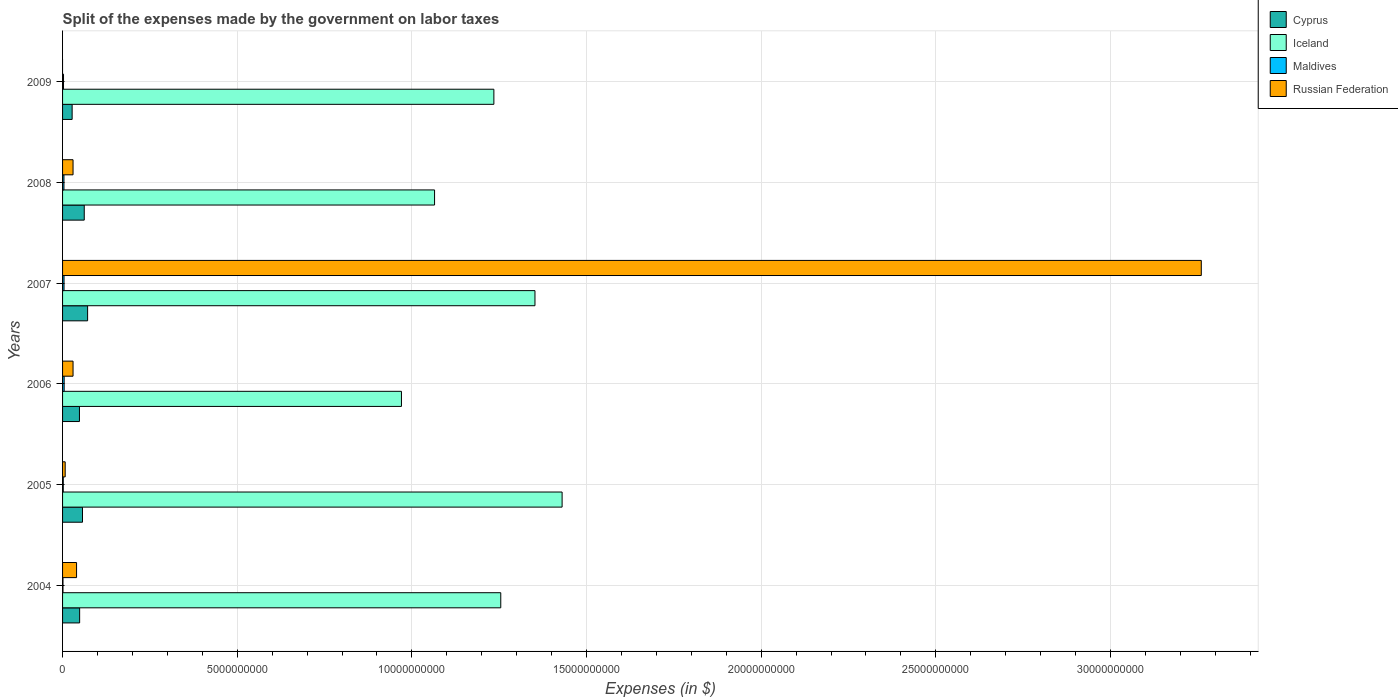How many groups of bars are there?
Make the answer very short. 6. Are the number of bars per tick equal to the number of legend labels?
Your answer should be compact. No. In how many cases, is the number of bars for a given year not equal to the number of legend labels?
Ensure brevity in your answer.  1. What is the expenses made by the government on labor taxes in Maldives in 2005?
Your answer should be very brief. 2.02e+07. Across all years, what is the maximum expenses made by the government on labor taxes in Iceland?
Provide a short and direct response. 1.43e+1. In which year was the expenses made by the government on labor taxes in Cyprus maximum?
Offer a terse response. 2007. What is the total expenses made by the government on labor taxes in Iceland in the graph?
Ensure brevity in your answer.  7.31e+1. What is the difference between the expenses made by the government on labor taxes in Maldives in 2005 and that in 2007?
Make the answer very short. -2.16e+07. What is the difference between the expenses made by the government on labor taxes in Cyprus in 2004 and the expenses made by the government on labor taxes in Russian Federation in 2009?
Provide a succinct answer. 4.89e+08. What is the average expenses made by the government on labor taxes in Cyprus per year?
Your answer should be compact. 5.26e+08. In the year 2007, what is the difference between the expenses made by the government on labor taxes in Maldives and expenses made by the government on labor taxes in Iceland?
Your answer should be very brief. -1.35e+1. In how many years, is the expenses made by the government on labor taxes in Maldives greater than 3000000000 $?
Offer a terse response. 0. What is the ratio of the expenses made by the government on labor taxes in Cyprus in 2006 to that in 2007?
Ensure brevity in your answer.  0.67. Is the expenses made by the government on labor taxes in Iceland in 2005 less than that in 2007?
Your answer should be very brief. No. What is the difference between the highest and the second highest expenses made by the government on labor taxes in Iceland?
Provide a short and direct response. 7.77e+08. What is the difference between the highest and the lowest expenses made by the government on labor taxes in Maldives?
Your answer should be compact. 3.34e+07. Is it the case that in every year, the sum of the expenses made by the government on labor taxes in Cyprus and expenses made by the government on labor taxes in Russian Federation is greater than the expenses made by the government on labor taxes in Iceland?
Keep it short and to the point. No. How many bars are there?
Provide a short and direct response. 23. Are all the bars in the graph horizontal?
Your answer should be very brief. Yes. How many years are there in the graph?
Ensure brevity in your answer.  6. Does the graph contain any zero values?
Give a very brief answer. Yes. How many legend labels are there?
Your answer should be very brief. 4. How are the legend labels stacked?
Your response must be concise. Vertical. What is the title of the graph?
Keep it short and to the point. Split of the expenses made by the government on labor taxes. What is the label or title of the X-axis?
Keep it short and to the point. Expenses (in $). What is the label or title of the Y-axis?
Offer a terse response. Years. What is the Expenses (in $) in Cyprus in 2004?
Ensure brevity in your answer.  4.89e+08. What is the Expenses (in $) in Iceland in 2004?
Offer a terse response. 1.25e+1. What is the Expenses (in $) in Maldives in 2004?
Your response must be concise. 1.22e+07. What is the Expenses (in $) in Russian Federation in 2004?
Your answer should be compact. 4.01e+08. What is the Expenses (in $) in Cyprus in 2005?
Offer a terse response. 5.71e+08. What is the Expenses (in $) of Iceland in 2005?
Make the answer very short. 1.43e+1. What is the Expenses (in $) in Maldives in 2005?
Make the answer very short. 2.02e+07. What is the Expenses (in $) in Russian Federation in 2005?
Your answer should be compact. 7.50e+07. What is the Expenses (in $) of Cyprus in 2006?
Offer a terse response. 4.84e+08. What is the Expenses (in $) in Iceland in 2006?
Offer a terse response. 9.70e+09. What is the Expenses (in $) in Maldives in 2006?
Give a very brief answer. 4.56e+07. What is the Expenses (in $) of Russian Federation in 2006?
Give a very brief answer. 3.00e+08. What is the Expenses (in $) of Cyprus in 2007?
Provide a succinct answer. 7.17e+08. What is the Expenses (in $) in Iceland in 2007?
Provide a succinct answer. 1.35e+1. What is the Expenses (in $) of Maldives in 2007?
Give a very brief answer. 4.18e+07. What is the Expenses (in $) of Russian Federation in 2007?
Offer a very short reply. 3.26e+1. What is the Expenses (in $) of Cyprus in 2008?
Ensure brevity in your answer.  6.21e+08. What is the Expenses (in $) of Iceland in 2008?
Make the answer very short. 1.06e+1. What is the Expenses (in $) in Maldives in 2008?
Offer a terse response. 3.97e+07. What is the Expenses (in $) of Russian Federation in 2008?
Your answer should be compact. 3.00e+08. What is the Expenses (in $) of Cyprus in 2009?
Give a very brief answer. 2.74e+08. What is the Expenses (in $) of Iceland in 2009?
Offer a terse response. 1.23e+1. What is the Expenses (in $) of Maldives in 2009?
Make the answer very short. 2.71e+07. Across all years, what is the maximum Expenses (in $) of Cyprus?
Your answer should be very brief. 7.17e+08. Across all years, what is the maximum Expenses (in $) in Iceland?
Ensure brevity in your answer.  1.43e+1. Across all years, what is the maximum Expenses (in $) in Maldives?
Your answer should be compact. 4.56e+07. Across all years, what is the maximum Expenses (in $) in Russian Federation?
Make the answer very short. 3.26e+1. Across all years, what is the minimum Expenses (in $) of Cyprus?
Keep it short and to the point. 2.74e+08. Across all years, what is the minimum Expenses (in $) in Iceland?
Offer a very short reply. 9.70e+09. Across all years, what is the minimum Expenses (in $) of Maldives?
Your answer should be very brief. 1.22e+07. What is the total Expenses (in $) of Cyprus in the graph?
Give a very brief answer. 3.16e+09. What is the total Expenses (in $) of Iceland in the graph?
Ensure brevity in your answer.  7.31e+1. What is the total Expenses (in $) in Maldives in the graph?
Keep it short and to the point. 1.87e+08. What is the total Expenses (in $) of Russian Federation in the graph?
Give a very brief answer. 3.37e+1. What is the difference between the Expenses (in $) of Cyprus in 2004 and that in 2005?
Make the answer very short. -8.18e+07. What is the difference between the Expenses (in $) in Iceland in 2004 and that in 2005?
Ensure brevity in your answer.  -1.76e+09. What is the difference between the Expenses (in $) of Maldives in 2004 and that in 2005?
Provide a succinct answer. -8.00e+06. What is the difference between the Expenses (in $) of Russian Federation in 2004 and that in 2005?
Your answer should be compact. 3.26e+08. What is the difference between the Expenses (in $) of Cyprus in 2004 and that in 2006?
Provide a short and direct response. 5.47e+06. What is the difference between the Expenses (in $) of Iceland in 2004 and that in 2006?
Provide a short and direct response. 2.84e+09. What is the difference between the Expenses (in $) of Maldives in 2004 and that in 2006?
Give a very brief answer. -3.34e+07. What is the difference between the Expenses (in $) in Russian Federation in 2004 and that in 2006?
Provide a succinct answer. 1.01e+08. What is the difference between the Expenses (in $) in Cyprus in 2004 and that in 2007?
Ensure brevity in your answer.  -2.28e+08. What is the difference between the Expenses (in $) in Iceland in 2004 and that in 2007?
Offer a very short reply. -9.79e+08. What is the difference between the Expenses (in $) of Maldives in 2004 and that in 2007?
Provide a short and direct response. -2.96e+07. What is the difference between the Expenses (in $) of Russian Federation in 2004 and that in 2007?
Ensure brevity in your answer.  -3.22e+1. What is the difference between the Expenses (in $) in Cyprus in 2004 and that in 2008?
Ensure brevity in your answer.  -1.32e+08. What is the difference between the Expenses (in $) in Iceland in 2004 and that in 2008?
Provide a succinct answer. 1.90e+09. What is the difference between the Expenses (in $) of Maldives in 2004 and that in 2008?
Your response must be concise. -2.75e+07. What is the difference between the Expenses (in $) in Russian Federation in 2004 and that in 2008?
Your response must be concise. 1.01e+08. What is the difference between the Expenses (in $) of Cyprus in 2004 and that in 2009?
Provide a succinct answer. 2.15e+08. What is the difference between the Expenses (in $) of Iceland in 2004 and that in 2009?
Offer a terse response. 1.97e+08. What is the difference between the Expenses (in $) of Maldives in 2004 and that in 2009?
Offer a very short reply. -1.49e+07. What is the difference between the Expenses (in $) of Cyprus in 2005 and that in 2006?
Give a very brief answer. 8.73e+07. What is the difference between the Expenses (in $) of Iceland in 2005 and that in 2006?
Make the answer very short. 4.60e+09. What is the difference between the Expenses (in $) in Maldives in 2005 and that in 2006?
Give a very brief answer. -2.54e+07. What is the difference between the Expenses (in $) in Russian Federation in 2005 and that in 2006?
Your response must be concise. -2.25e+08. What is the difference between the Expenses (in $) in Cyprus in 2005 and that in 2007?
Keep it short and to the point. -1.46e+08. What is the difference between the Expenses (in $) in Iceland in 2005 and that in 2007?
Give a very brief answer. 7.77e+08. What is the difference between the Expenses (in $) in Maldives in 2005 and that in 2007?
Your answer should be compact. -2.16e+07. What is the difference between the Expenses (in $) of Russian Federation in 2005 and that in 2007?
Give a very brief answer. -3.25e+1. What is the difference between the Expenses (in $) in Cyprus in 2005 and that in 2008?
Your answer should be compact. -5.01e+07. What is the difference between the Expenses (in $) of Iceland in 2005 and that in 2008?
Your response must be concise. 3.65e+09. What is the difference between the Expenses (in $) of Maldives in 2005 and that in 2008?
Keep it short and to the point. -1.95e+07. What is the difference between the Expenses (in $) in Russian Federation in 2005 and that in 2008?
Provide a succinct answer. -2.25e+08. What is the difference between the Expenses (in $) in Cyprus in 2005 and that in 2009?
Give a very brief answer. 2.97e+08. What is the difference between the Expenses (in $) of Iceland in 2005 and that in 2009?
Offer a terse response. 1.95e+09. What is the difference between the Expenses (in $) in Maldives in 2005 and that in 2009?
Offer a very short reply. -6.90e+06. What is the difference between the Expenses (in $) of Cyprus in 2006 and that in 2007?
Offer a very short reply. -2.33e+08. What is the difference between the Expenses (in $) of Iceland in 2006 and that in 2007?
Make the answer very short. -3.82e+09. What is the difference between the Expenses (in $) of Maldives in 2006 and that in 2007?
Your response must be concise. 3.80e+06. What is the difference between the Expenses (in $) in Russian Federation in 2006 and that in 2007?
Provide a succinct answer. -3.23e+1. What is the difference between the Expenses (in $) in Cyprus in 2006 and that in 2008?
Offer a terse response. -1.37e+08. What is the difference between the Expenses (in $) in Iceland in 2006 and that in 2008?
Offer a very short reply. -9.48e+08. What is the difference between the Expenses (in $) of Maldives in 2006 and that in 2008?
Make the answer very short. 5.90e+06. What is the difference between the Expenses (in $) of Russian Federation in 2006 and that in 2008?
Your answer should be very brief. 0. What is the difference between the Expenses (in $) in Cyprus in 2006 and that in 2009?
Ensure brevity in your answer.  2.09e+08. What is the difference between the Expenses (in $) of Iceland in 2006 and that in 2009?
Offer a very short reply. -2.65e+09. What is the difference between the Expenses (in $) in Maldives in 2006 and that in 2009?
Keep it short and to the point. 1.85e+07. What is the difference between the Expenses (in $) in Cyprus in 2007 and that in 2008?
Provide a short and direct response. 9.60e+07. What is the difference between the Expenses (in $) of Iceland in 2007 and that in 2008?
Ensure brevity in your answer.  2.87e+09. What is the difference between the Expenses (in $) in Maldives in 2007 and that in 2008?
Ensure brevity in your answer.  2.10e+06. What is the difference between the Expenses (in $) of Russian Federation in 2007 and that in 2008?
Provide a succinct answer. 3.23e+1. What is the difference between the Expenses (in $) in Cyprus in 2007 and that in 2009?
Keep it short and to the point. 4.43e+08. What is the difference between the Expenses (in $) of Iceland in 2007 and that in 2009?
Your answer should be very brief. 1.18e+09. What is the difference between the Expenses (in $) of Maldives in 2007 and that in 2009?
Keep it short and to the point. 1.47e+07. What is the difference between the Expenses (in $) of Cyprus in 2008 and that in 2009?
Make the answer very short. 3.47e+08. What is the difference between the Expenses (in $) of Iceland in 2008 and that in 2009?
Keep it short and to the point. -1.70e+09. What is the difference between the Expenses (in $) of Maldives in 2008 and that in 2009?
Your response must be concise. 1.26e+07. What is the difference between the Expenses (in $) of Cyprus in 2004 and the Expenses (in $) of Iceland in 2005?
Give a very brief answer. -1.38e+1. What is the difference between the Expenses (in $) in Cyprus in 2004 and the Expenses (in $) in Maldives in 2005?
Offer a very short reply. 4.69e+08. What is the difference between the Expenses (in $) in Cyprus in 2004 and the Expenses (in $) in Russian Federation in 2005?
Keep it short and to the point. 4.14e+08. What is the difference between the Expenses (in $) in Iceland in 2004 and the Expenses (in $) in Maldives in 2005?
Keep it short and to the point. 1.25e+1. What is the difference between the Expenses (in $) in Iceland in 2004 and the Expenses (in $) in Russian Federation in 2005?
Provide a succinct answer. 1.25e+1. What is the difference between the Expenses (in $) of Maldives in 2004 and the Expenses (in $) of Russian Federation in 2005?
Ensure brevity in your answer.  -6.28e+07. What is the difference between the Expenses (in $) in Cyprus in 2004 and the Expenses (in $) in Iceland in 2006?
Keep it short and to the point. -9.21e+09. What is the difference between the Expenses (in $) of Cyprus in 2004 and the Expenses (in $) of Maldives in 2006?
Offer a very short reply. 4.43e+08. What is the difference between the Expenses (in $) in Cyprus in 2004 and the Expenses (in $) in Russian Federation in 2006?
Provide a short and direct response. 1.89e+08. What is the difference between the Expenses (in $) in Iceland in 2004 and the Expenses (in $) in Maldives in 2006?
Offer a very short reply. 1.25e+1. What is the difference between the Expenses (in $) of Iceland in 2004 and the Expenses (in $) of Russian Federation in 2006?
Give a very brief answer. 1.22e+1. What is the difference between the Expenses (in $) in Maldives in 2004 and the Expenses (in $) in Russian Federation in 2006?
Give a very brief answer. -2.88e+08. What is the difference between the Expenses (in $) of Cyprus in 2004 and the Expenses (in $) of Iceland in 2007?
Offer a terse response. -1.30e+1. What is the difference between the Expenses (in $) in Cyprus in 2004 and the Expenses (in $) in Maldives in 2007?
Provide a short and direct response. 4.47e+08. What is the difference between the Expenses (in $) of Cyprus in 2004 and the Expenses (in $) of Russian Federation in 2007?
Offer a terse response. -3.21e+1. What is the difference between the Expenses (in $) in Iceland in 2004 and the Expenses (in $) in Maldives in 2007?
Offer a very short reply. 1.25e+1. What is the difference between the Expenses (in $) of Iceland in 2004 and the Expenses (in $) of Russian Federation in 2007?
Your answer should be very brief. -2.01e+1. What is the difference between the Expenses (in $) in Maldives in 2004 and the Expenses (in $) in Russian Federation in 2007?
Keep it short and to the point. -3.26e+1. What is the difference between the Expenses (in $) of Cyprus in 2004 and the Expenses (in $) of Iceland in 2008?
Your response must be concise. -1.02e+1. What is the difference between the Expenses (in $) of Cyprus in 2004 and the Expenses (in $) of Maldives in 2008?
Ensure brevity in your answer.  4.49e+08. What is the difference between the Expenses (in $) in Cyprus in 2004 and the Expenses (in $) in Russian Federation in 2008?
Make the answer very short. 1.89e+08. What is the difference between the Expenses (in $) in Iceland in 2004 and the Expenses (in $) in Maldives in 2008?
Make the answer very short. 1.25e+1. What is the difference between the Expenses (in $) of Iceland in 2004 and the Expenses (in $) of Russian Federation in 2008?
Your answer should be compact. 1.22e+1. What is the difference between the Expenses (in $) of Maldives in 2004 and the Expenses (in $) of Russian Federation in 2008?
Make the answer very short. -2.88e+08. What is the difference between the Expenses (in $) of Cyprus in 2004 and the Expenses (in $) of Iceland in 2009?
Offer a terse response. -1.19e+1. What is the difference between the Expenses (in $) of Cyprus in 2004 and the Expenses (in $) of Maldives in 2009?
Your answer should be very brief. 4.62e+08. What is the difference between the Expenses (in $) in Iceland in 2004 and the Expenses (in $) in Maldives in 2009?
Ensure brevity in your answer.  1.25e+1. What is the difference between the Expenses (in $) of Cyprus in 2005 and the Expenses (in $) of Iceland in 2006?
Your answer should be very brief. -9.13e+09. What is the difference between the Expenses (in $) in Cyprus in 2005 and the Expenses (in $) in Maldives in 2006?
Your answer should be compact. 5.25e+08. What is the difference between the Expenses (in $) in Cyprus in 2005 and the Expenses (in $) in Russian Federation in 2006?
Offer a terse response. 2.71e+08. What is the difference between the Expenses (in $) of Iceland in 2005 and the Expenses (in $) of Maldives in 2006?
Provide a short and direct response. 1.43e+1. What is the difference between the Expenses (in $) of Iceland in 2005 and the Expenses (in $) of Russian Federation in 2006?
Offer a very short reply. 1.40e+1. What is the difference between the Expenses (in $) of Maldives in 2005 and the Expenses (in $) of Russian Federation in 2006?
Offer a very short reply. -2.80e+08. What is the difference between the Expenses (in $) in Cyprus in 2005 and the Expenses (in $) in Iceland in 2007?
Ensure brevity in your answer.  -1.30e+1. What is the difference between the Expenses (in $) in Cyprus in 2005 and the Expenses (in $) in Maldives in 2007?
Keep it short and to the point. 5.29e+08. What is the difference between the Expenses (in $) in Cyprus in 2005 and the Expenses (in $) in Russian Federation in 2007?
Keep it short and to the point. -3.20e+1. What is the difference between the Expenses (in $) of Iceland in 2005 and the Expenses (in $) of Maldives in 2007?
Ensure brevity in your answer.  1.43e+1. What is the difference between the Expenses (in $) in Iceland in 2005 and the Expenses (in $) in Russian Federation in 2007?
Offer a very short reply. -1.83e+1. What is the difference between the Expenses (in $) in Maldives in 2005 and the Expenses (in $) in Russian Federation in 2007?
Make the answer very short. -3.26e+1. What is the difference between the Expenses (in $) in Cyprus in 2005 and the Expenses (in $) in Iceland in 2008?
Ensure brevity in your answer.  -1.01e+1. What is the difference between the Expenses (in $) of Cyprus in 2005 and the Expenses (in $) of Maldives in 2008?
Provide a short and direct response. 5.31e+08. What is the difference between the Expenses (in $) in Cyprus in 2005 and the Expenses (in $) in Russian Federation in 2008?
Offer a very short reply. 2.71e+08. What is the difference between the Expenses (in $) in Iceland in 2005 and the Expenses (in $) in Maldives in 2008?
Offer a very short reply. 1.43e+1. What is the difference between the Expenses (in $) in Iceland in 2005 and the Expenses (in $) in Russian Federation in 2008?
Offer a terse response. 1.40e+1. What is the difference between the Expenses (in $) of Maldives in 2005 and the Expenses (in $) of Russian Federation in 2008?
Your response must be concise. -2.80e+08. What is the difference between the Expenses (in $) in Cyprus in 2005 and the Expenses (in $) in Iceland in 2009?
Make the answer very short. -1.18e+1. What is the difference between the Expenses (in $) in Cyprus in 2005 and the Expenses (in $) in Maldives in 2009?
Provide a short and direct response. 5.44e+08. What is the difference between the Expenses (in $) in Iceland in 2005 and the Expenses (in $) in Maldives in 2009?
Provide a succinct answer. 1.43e+1. What is the difference between the Expenses (in $) of Cyprus in 2006 and the Expenses (in $) of Iceland in 2007?
Your answer should be very brief. -1.30e+1. What is the difference between the Expenses (in $) in Cyprus in 2006 and the Expenses (in $) in Maldives in 2007?
Give a very brief answer. 4.42e+08. What is the difference between the Expenses (in $) of Cyprus in 2006 and the Expenses (in $) of Russian Federation in 2007?
Give a very brief answer. -3.21e+1. What is the difference between the Expenses (in $) in Iceland in 2006 and the Expenses (in $) in Maldives in 2007?
Provide a succinct answer. 9.66e+09. What is the difference between the Expenses (in $) in Iceland in 2006 and the Expenses (in $) in Russian Federation in 2007?
Ensure brevity in your answer.  -2.29e+1. What is the difference between the Expenses (in $) of Maldives in 2006 and the Expenses (in $) of Russian Federation in 2007?
Make the answer very short. -3.26e+1. What is the difference between the Expenses (in $) of Cyprus in 2006 and the Expenses (in $) of Iceland in 2008?
Give a very brief answer. -1.02e+1. What is the difference between the Expenses (in $) in Cyprus in 2006 and the Expenses (in $) in Maldives in 2008?
Keep it short and to the point. 4.44e+08. What is the difference between the Expenses (in $) in Cyprus in 2006 and the Expenses (in $) in Russian Federation in 2008?
Offer a very short reply. 1.84e+08. What is the difference between the Expenses (in $) in Iceland in 2006 and the Expenses (in $) in Maldives in 2008?
Give a very brief answer. 9.66e+09. What is the difference between the Expenses (in $) of Iceland in 2006 and the Expenses (in $) of Russian Federation in 2008?
Your answer should be compact. 9.40e+09. What is the difference between the Expenses (in $) of Maldives in 2006 and the Expenses (in $) of Russian Federation in 2008?
Make the answer very short. -2.54e+08. What is the difference between the Expenses (in $) of Cyprus in 2006 and the Expenses (in $) of Iceland in 2009?
Your response must be concise. -1.19e+1. What is the difference between the Expenses (in $) in Cyprus in 2006 and the Expenses (in $) in Maldives in 2009?
Offer a very short reply. 4.56e+08. What is the difference between the Expenses (in $) in Iceland in 2006 and the Expenses (in $) in Maldives in 2009?
Give a very brief answer. 9.67e+09. What is the difference between the Expenses (in $) of Cyprus in 2007 and the Expenses (in $) of Iceland in 2008?
Give a very brief answer. -9.93e+09. What is the difference between the Expenses (in $) of Cyprus in 2007 and the Expenses (in $) of Maldives in 2008?
Your answer should be compact. 6.77e+08. What is the difference between the Expenses (in $) in Cyprus in 2007 and the Expenses (in $) in Russian Federation in 2008?
Ensure brevity in your answer.  4.17e+08. What is the difference between the Expenses (in $) in Iceland in 2007 and the Expenses (in $) in Maldives in 2008?
Provide a short and direct response. 1.35e+1. What is the difference between the Expenses (in $) of Iceland in 2007 and the Expenses (in $) of Russian Federation in 2008?
Your answer should be compact. 1.32e+1. What is the difference between the Expenses (in $) of Maldives in 2007 and the Expenses (in $) of Russian Federation in 2008?
Offer a terse response. -2.58e+08. What is the difference between the Expenses (in $) in Cyprus in 2007 and the Expenses (in $) in Iceland in 2009?
Give a very brief answer. -1.16e+1. What is the difference between the Expenses (in $) in Cyprus in 2007 and the Expenses (in $) in Maldives in 2009?
Your answer should be compact. 6.90e+08. What is the difference between the Expenses (in $) in Iceland in 2007 and the Expenses (in $) in Maldives in 2009?
Your response must be concise. 1.35e+1. What is the difference between the Expenses (in $) of Cyprus in 2008 and the Expenses (in $) of Iceland in 2009?
Provide a short and direct response. -1.17e+1. What is the difference between the Expenses (in $) of Cyprus in 2008 and the Expenses (in $) of Maldives in 2009?
Offer a very short reply. 5.94e+08. What is the difference between the Expenses (in $) in Iceland in 2008 and the Expenses (in $) in Maldives in 2009?
Provide a short and direct response. 1.06e+1. What is the average Expenses (in $) in Cyprus per year?
Your answer should be very brief. 5.26e+08. What is the average Expenses (in $) of Iceland per year?
Make the answer very short. 1.22e+1. What is the average Expenses (in $) in Maldives per year?
Offer a terse response. 3.11e+07. What is the average Expenses (in $) of Russian Federation per year?
Ensure brevity in your answer.  5.61e+09. In the year 2004, what is the difference between the Expenses (in $) of Cyprus and Expenses (in $) of Iceland?
Your answer should be very brief. -1.21e+1. In the year 2004, what is the difference between the Expenses (in $) of Cyprus and Expenses (in $) of Maldives?
Offer a very short reply. 4.77e+08. In the year 2004, what is the difference between the Expenses (in $) of Cyprus and Expenses (in $) of Russian Federation?
Keep it short and to the point. 8.83e+07. In the year 2004, what is the difference between the Expenses (in $) in Iceland and Expenses (in $) in Maldives?
Make the answer very short. 1.25e+1. In the year 2004, what is the difference between the Expenses (in $) of Iceland and Expenses (in $) of Russian Federation?
Keep it short and to the point. 1.21e+1. In the year 2004, what is the difference between the Expenses (in $) of Maldives and Expenses (in $) of Russian Federation?
Offer a terse response. -3.89e+08. In the year 2005, what is the difference between the Expenses (in $) in Cyprus and Expenses (in $) in Iceland?
Give a very brief answer. -1.37e+1. In the year 2005, what is the difference between the Expenses (in $) of Cyprus and Expenses (in $) of Maldives?
Offer a very short reply. 5.51e+08. In the year 2005, what is the difference between the Expenses (in $) in Cyprus and Expenses (in $) in Russian Federation?
Keep it short and to the point. 4.96e+08. In the year 2005, what is the difference between the Expenses (in $) of Iceland and Expenses (in $) of Maldives?
Ensure brevity in your answer.  1.43e+1. In the year 2005, what is the difference between the Expenses (in $) of Iceland and Expenses (in $) of Russian Federation?
Make the answer very short. 1.42e+1. In the year 2005, what is the difference between the Expenses (in $) of Maldives and Expenses (in $) of Russian Federation?
Provide a succinct answer. -5.48e+07. In the year 2006, what is the difference between the Expenses (in $) in Cyprus and Expenses (in $) in Iceland?
Provide a short and direct response. -9.22e+09. In the year 2006, what is the difference between the Expenses (in $) in Cyprus and Expenses (in $) in Maldives?
Keep it short and to the point. 4.38e+08. In the year 2006, what is the difference between the Expenses (in $) of Cyprus and Expenses (in $) of Russian Federation?
Your answer should be very brief. 1.84e+08. In the year 2006, what is the difference between the Expenses (in $) in Iceland and Expenses (in $) in Maldives?
Offer a very short reply. 9.66e+09. In the year 2006, what is the difference between the Expenses (in $) in Iceland and Expenses (in $) in Russian Federation?
Offer a very short reply. 9.40e+09. In the year 2006, what is the difference between the Expenses (in $) of Maldives and Expenses (in $) of Russian Federation?
Give a very brief answer. -2.54e+08. In the year 2007, what is the difference between the Expenses (in $) of Cyprus and Expenses (in $) of Iceland?
Your answer should be very brief. -1.28e+1. In the year 2007, what is the difference between the Expenses (in $) of Cyprus and Expenses (in $) of Maldives?
Your answer should be compact. 6.75e+08. In the year 2007, what is the difference between the Expenses (in $) of Cyprus and Expenses (in $) of Russian Federation?
Keep it short and to the point. -3.19e+1. In the year 2007, what is the difference between the Expenses (in $) of Iceland and Expenses (in $) of Maldives?
Your answer should be compact. 1.35e+1. In the year 2007, what is the difference between the Expenses (in $) in Iceland and Expenses (in $) in Russian Federation?
Provide a short and direct response. -1.91e+1. In the year 2007, what is the difference between the Expenses (in $) in Maldives and Expenses (in $) in Russian Federation?
Make the answer very short. -3.26e+1. In the year 2008, what is the difference between the Expenses (in $) of Cyprus and Expenses (in $) of Iceland?
Give a very brief answer. -1.00e+1. In the year 2008, what is the difference between the Expenses (in $) of Cyprus and Expenses (in $) of Maldives?
Your answer should be compact. 5.81e+08. In the year 2008, what is the difference between the Expenses (in $) of Cyprus and Expenses (in $) of Russian Federation?
Make the answer very short. 3.21e+08. In the year 2008, what is the difference between the Expenses (in $) in Iceland and Expenses (in $) in Maldives?
Ensure brevity in your answer.  1.06e+1. In the year 2008, what is the difference between the Expenses (in $) in Iceland and Expenses (in $) in Russian Federation?
Provide a short and direct response. 1.03e+1. In the year 2008, what is the difference between the Expenses (in $) of Maldives and Expenses (in $) of Russian Federation?
Ensure brevity in your answer.  -2.60e+08. In the year 2009, what is the difference between the Expenses (in $) in Cyprus and Expenses (in $) in Iceland?
Give a very brief answer. -1.21e+1. In the year 2009, what is the difference between the Expenses (in $) of Cyprus and Expenses (in $) of Maldives?
Offer a very short reply. 2.47e+08. In the year 2009, what is the difference between the Expenses (in $) of Iceland and Expenses (in $) of Maldives?
Your answer should be compact. 1.23e+1. What is the ratio of the Expenses (in $) of Cyprus in 2004 to that in 2005?
Your answer should be very brief. 0.86. What is the ratio of the Expenses (in $) of Iceland in 2004 to that in 2005?
Keep it short and to the point. 0.88. What is the ratio of the Expenses (in $) in Maldives in 2004 to that in 2005?
Offer a very short reply. 0.6. What is the ratio of the Expenses (in $) of Russian Federation in 2004 to that in 2005?
Make the answer very short. 5.34. What is the ratio of the Expenses (in $) of Cyprus in 2004 to that in 2006?
Offer a terse response. 1.01. What is the ratio of the Expenses (in $) of Iceland in 2004 to that in 2006?
Give a very brief answer. 1.29. What is the ratio of the Expenses (in $) of Maldives in 2004 to that in 2006?
Your answer should be very brief. 0.27. What is the ratio of the Expenses (in $) of Russian Federation in 2004 to that in 2006?
Give a very brief answer. 1.34. What is the ratio of the Expenses (in $) in Cyprus in 2004 to that in 2007?
Keep it short and to the point. 0.68. What is the ratio of the Expenses (in $) of Iceland in 2004 to that in 2007?
Ensure brevity in your answer.  0.93. What is the ratio of the Expenses (in $) of Maldives in 2004 to that in 2007?
Offer a very short reply. 0.29. What is the ratio of the Expenses (in $) of Russian Federation in 2004 to that in 2007?
Make the answer very short. 0.01. What is the ratio of the Expenses (in $) of Cyprus in 2004 to that in 2008?
Ensure brevity in your answer.  0.79. What is the ratio of the Expenses (in $) in Iceland in 2004 to that in 2008?
Give a very brief answer. 1.18. What is the ratio of the Expenses (in $) of Maldives in 2004 to that in 2008?
Your response must be concise. 0.31. What is the ratio of the Expenses (in $) in Russian Federation in 2004 to that in 2008?
Offer a terse response. 1.34. What is the ratio of the Expenses (in $) of Cyprus in 2004 to that in 2009?
Make the answer very short. 1.78. What is the ratio of the Expenses (in $) in Iceland in 2004 to that in 2009?
Make the answer very short. 1.02. What is the ratio of the Expenses (in $) of Maldives in 2004 to that in 2009?
Your answer should be compact. 0.45. What is the ratio of the Expenses (in $) of Cyprus in 2005 to that in 2006?
Ensure brevity in your answer.  1.18. What is the ratio of the Expenses (in $) of Iceland in 2005 to that in 2006?
Offer a terse response. 1.47. What is the ratio of the Expenses (in $) of Maldives in 2005 to that in 2006?
Your answer should be very brief. 0.44. What is the ratio of the Expenses (in $) of Cyprus in 2005 to that in 2007?
Your response must be concise. 0.8. What is the ratio of the Expenses (in $) of Iceland in 2005 to that in 2007?
Offer a terse response. 1.06. What is the ratio of the Expenses (in $) of Maldives in 2005 to that in 2007?
Keep it short and to the point. 0.48. What is the ratio of the Expenses (in $) of Russian Federation in 2005 to that in 2007?
Your answer should be very brief. 0. What is the ratio of the Expenses (in $) of Cyprus in 2005 to that in 2008?
Give a very brief answer. 0.92. What is the ratio of the Expenses (in $) of Iceland in 2005 to that in 2008?
Your answer should be compact. 1.34. What is the ratio of the Expenses (in $) of Maldives in 2005 to that in 2008?
Your response must be concise. 0.51. What is the ratio of the Expenses (in $) of Russian Federation in 2005 to that in 2008?
Provide a short and direct response. 0.25. What is the ratio of the Expenses (in $) in Cyprus in 2005 to that in 2009?
Provide a succinct answer. 2.08. What is the ratio of the Expenses (in $) in Iceland in 2005 to that in 2009?
Offer a very short reply. 1.16. What is the ratio of the Expenses (in $) in Maldives in 2005 to that in 2009?
Ensure brevity in your answer.  0.75. What is the ratio of the Expenses (in $) in Cyprus in 2006 to that in 2007?
Offer a terse response. 0.67. What is the ratio of the Expenses (in $) of Iceland in 2006 to that in 2007?
Give a very brief answer. 0.72. What is the ratio of the Expenses (in $) of Russian Federation in 2006 to that in 2007?
Ensure brevity in your answer.  0.01. What is the ratio of the Expenses (in $) in Cyprus in 2006 to that in 2008?
Your answer should be very brief. 0.78. What is the ratio of the Expenses (in $) of Iceland in 2006 to that in 2008?
Provide a short and direct response. 0.91. What is the ratio of the Expenses (in $) in Maldives in 2006 to that in 2008?
Your answer should be very brief. 1.15. What is the ratio of the Expenses (in $) in Cyprus in 2006 to that in 2009?
Ensure brevity in your answer.  1.76. What is the ratio of the Expenses (in $) in Iceland in 2006 to that in 2009?
Provide a short and direct response. 0.79. What is the ratio of the Expenses (in $) of Maldives in 2006 to that in 2009?
Keep it short and to the point. 1.68. What is the ratio of the Expenses (in $) of Cyprus in 2007 to that in 2008?
Your answer should be very brief. 1.15. What is the ratio of the Expenses (in $) in Iceland in 2007 to that in 2008?
Your answer should be very brief. 1.27. What is the ratio of the Expenses (in $) in Maldives in 2007 to that in 2008?
Offer a terse response. 1.05. What is the ratio of the Expenses (in $) of Russian Federation in 2007 to that in 2008?
Offer a very short reply. 108.67. What is the ratio of the Expenses (in $) of Cyprus in 2007 to that in 2009?
Your response must be concise. 2.62. What is the ratio of the Expenses (in $) of Iceland in 2007 to that in 2009?
Ensure brevity in your answer.  1.1. What is the ratio of the Expenses (in $) of Maldives in 2007 to that in 2009?
Your answer should be compact. 1.54. What is the ratio of the Expenses (in $) in Cyprus in 2008 to that in 2009?
Offer a terse response. 2.27. What is the ratio of the Expenses (in $) in Iceland in 2008 to that in 2009?
Provide a short and direct response. 0.86. What is the ratio of the Expenses (in $) of Maldives in 2008 to that in 2009?
Provide a short and direct response. 1.46. What is the difference between the highest and the second highest Expenses (in $) of Cyprus?
Offer a very short reply. 9.60e+07. What is the difference between the highest and the second highest Expenses (in $) in Iceland?
Keep it short and to the point. 7.77e+08. What is the difference between the highest and the second highest Expenses (in $) in Maldives?
Make the answer very short. 3.80e+06. What is the difference between the highest and the second highest Expenses (in $) of Russian Federation?
Make the answer very short. 3.22e+1. What is the difference between the highest and the lowest Expenses (in $) in Cyprus?
Offer a very short reply. 4.43e+08. What is the difference between the highest and the lowest Expenses (in $) of Iceland?
Offer a very short reply. 4.60e+09. What is the difference between the highest and the lowest Expenses (in $) in Maldives?
Offer a very short reply. 3.34e+07. What is the difference between the highest and the lowest Expenses (in $) in Russian Federation?
Give a very brief answer. 3.26e+1. 